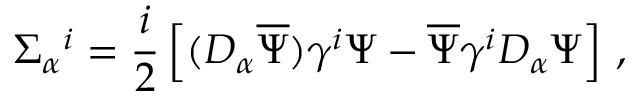<formula> <loc_0><loc_0><loc_500><loc_500>\Sigma _ { \alpha ^ { i } = \frac { i } { 2 } \left [ ( D _ { \alpha } \overline { \Psi } ) \gamma ^ { i } \Psi - \overline { \Psi } \gamma ^ { i } D _ { \alpha } \Psi \right ] \, ,</formula> 